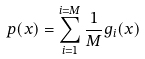<formula> <loc_0><loc_0><loc_500><loc_500>p ( x ) = \sum _ { i = 1 } ^ { i = M } \frac { 1 } { M } g _ { i } ( x )</formula> 